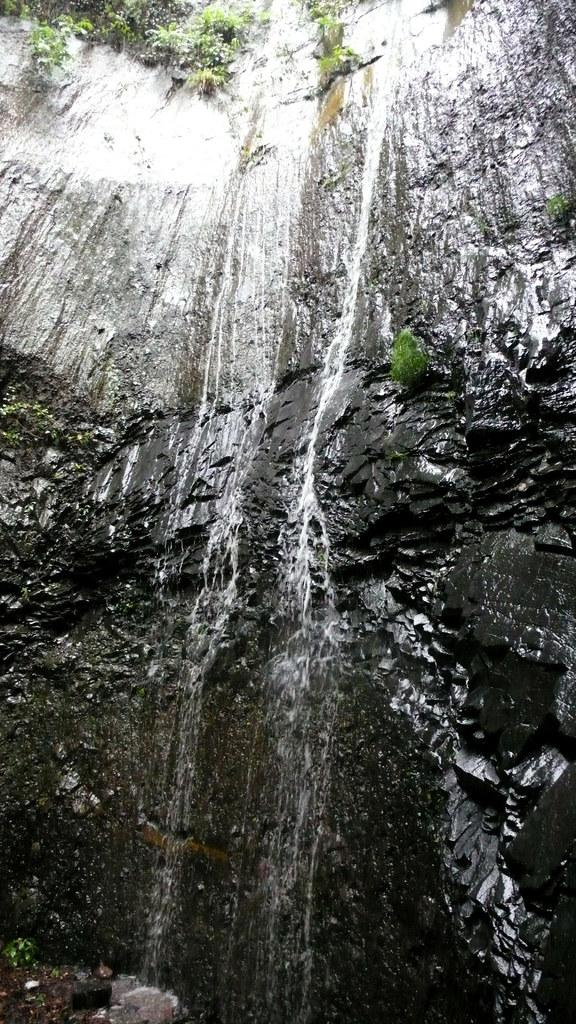What type of landform can be seen in the image? There is a hill in the image. What natural element is present alongside the hill? There is water visible in the image. What type of vegetation can be seen in the image? There are plants in the image. What type of texture can be seen on the bird's feathers in the image? There are no birds present in the image, so we cannot determine the texture of any bird's feathers. 